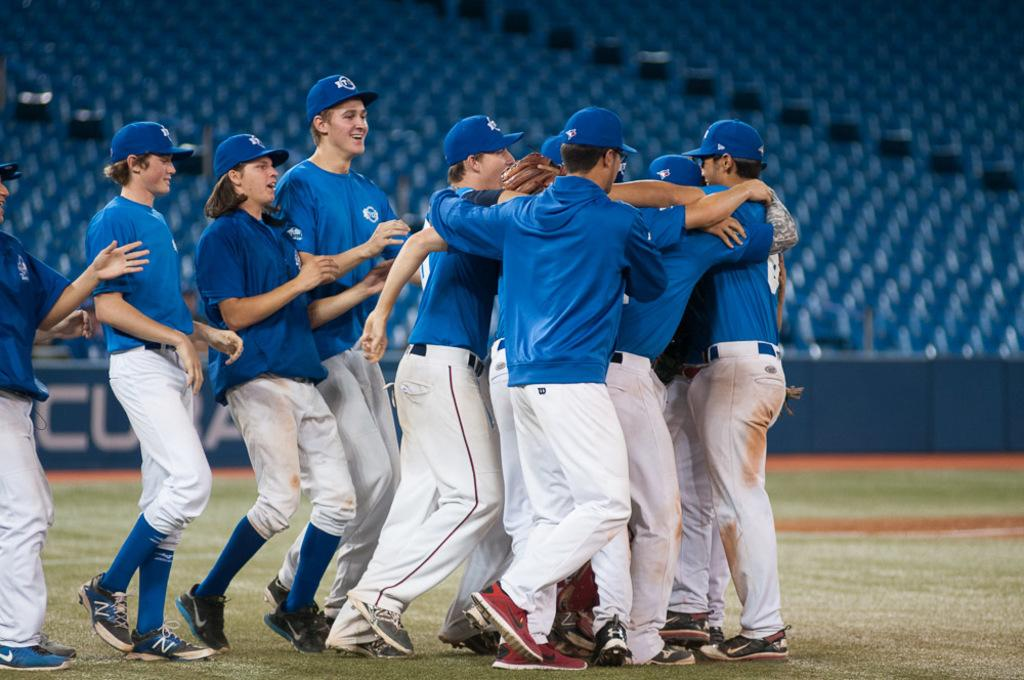What is the surface that the people are standing on in the image? The people are standing on the grass in the image. What can be seen hanging or displayed in the image? There is a banner with text in the image. What type of furniture is visible in the background of the image? Chairs are present in the background of the image. What grade of sugar is being used in the image? There is no sugar present in the image, so it is not possible to determine the grade of sugar being used. How does the skate interact with the people in the image? There is no skate present in the image, so it is not possible to describe any interaction between a skate and the people. 